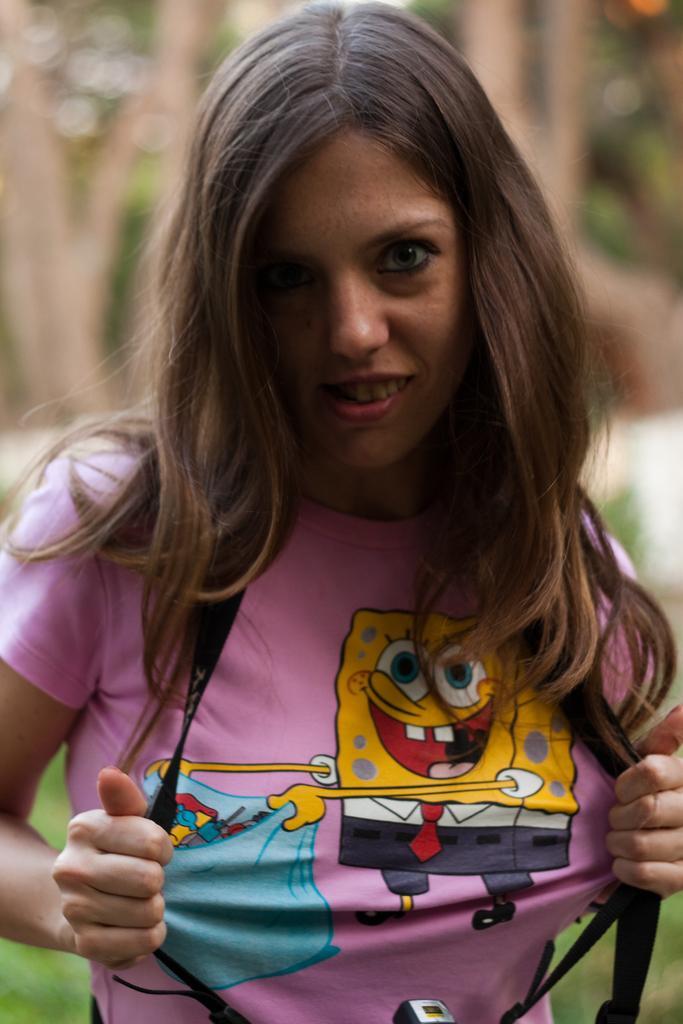Please provide a concise description of this image. In this image we can see a woman. In the background there are trees. 